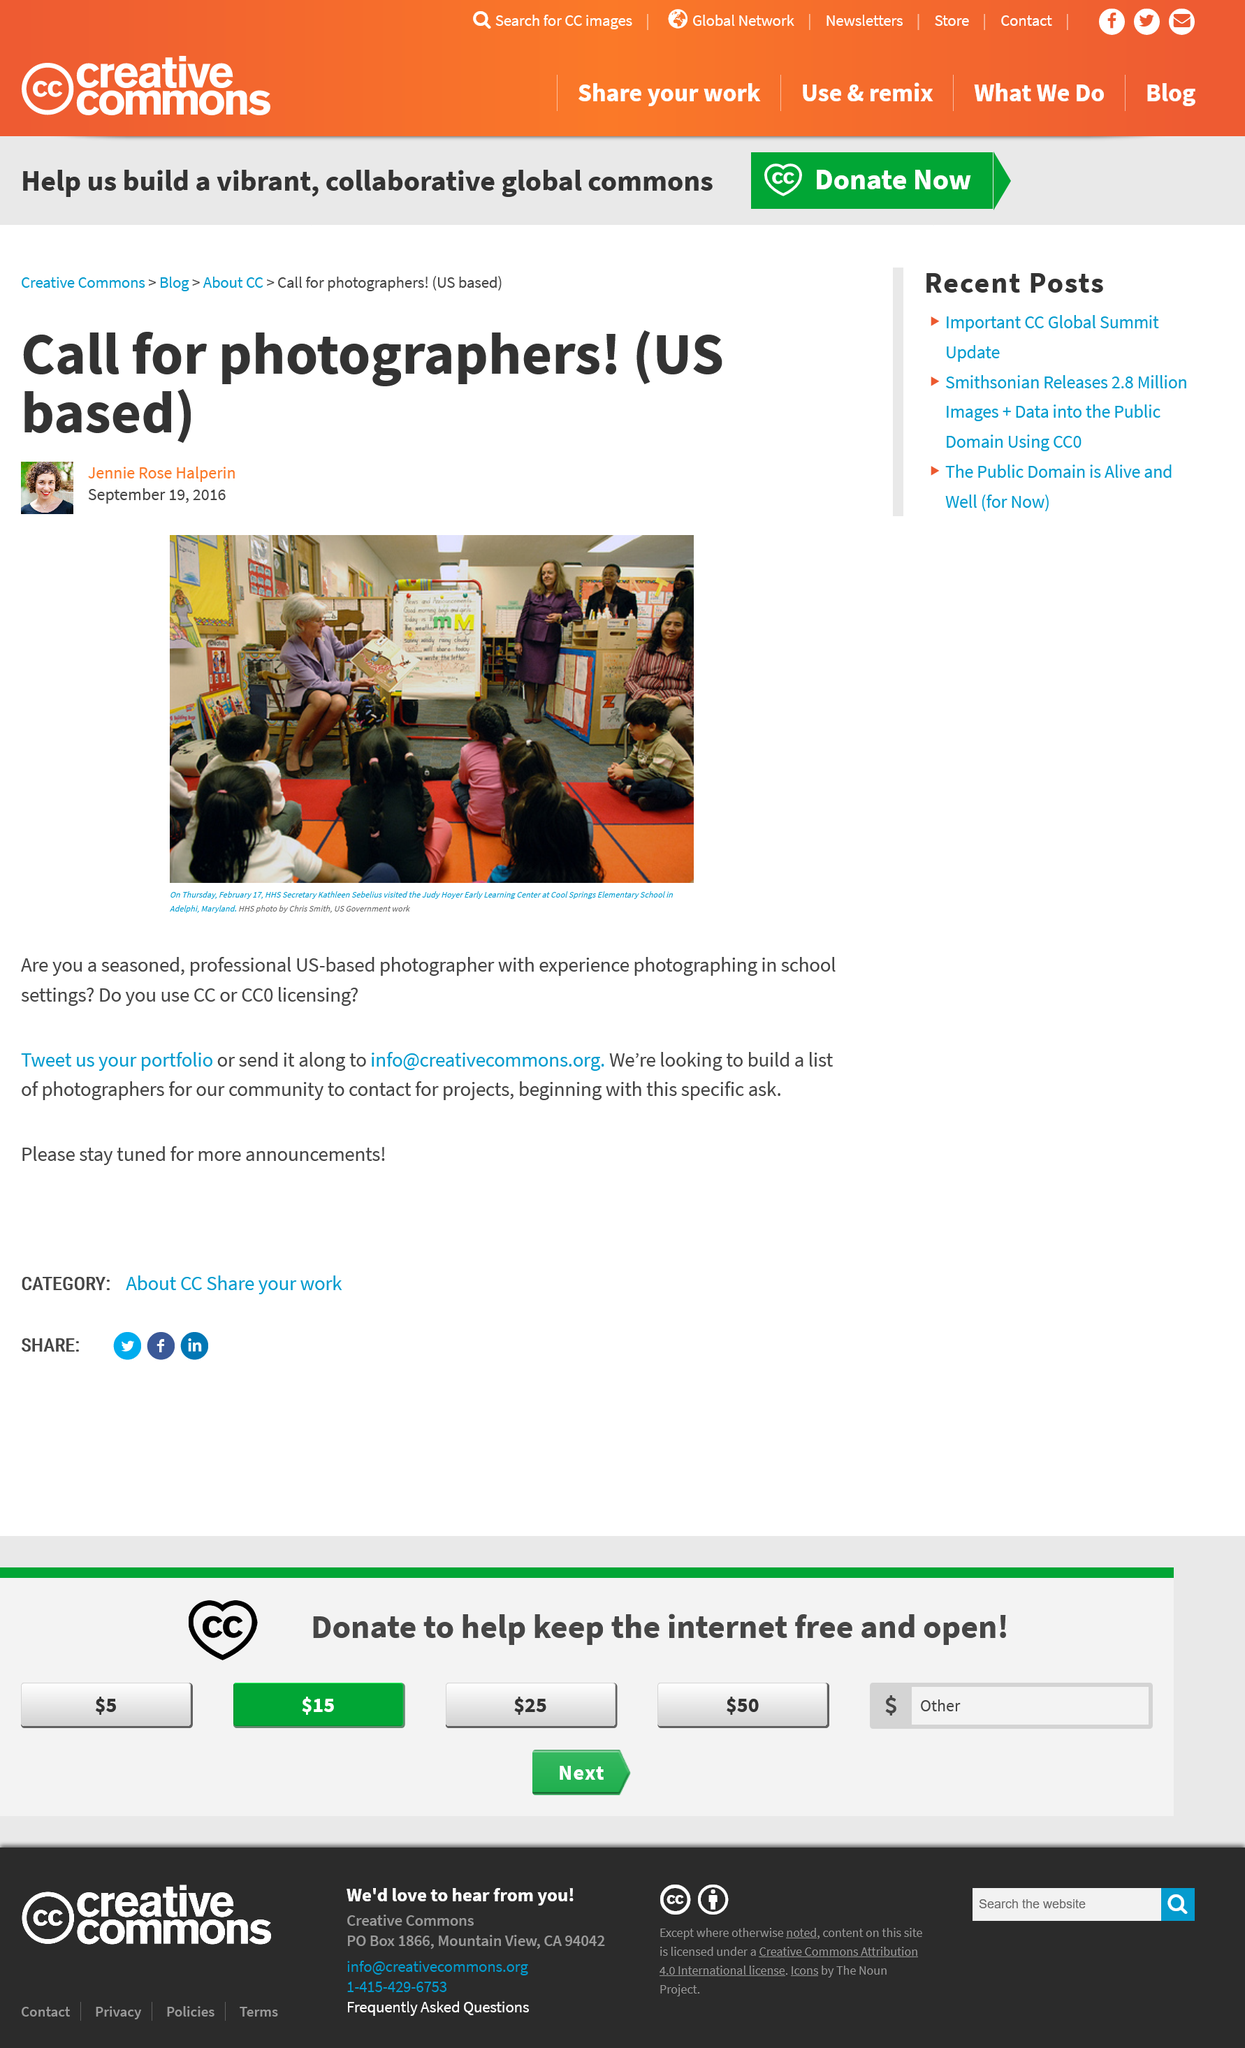Outline some significant characteristics in this image. The main image was taken on Thursday, February 17th, as determined by the metadata associated with the image. The CC is actively seeking photographers from the United States to collaborate with in various photographic projects. The Judy Hoyer Early Learning Center is situated at Cool Springs Elementary School in Adelphi, Maryland. 